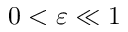Convert formula to latex. <formula><loc_0><loc_0><loc_500><loc_500>0 < \varepsilon \ll 1</formula> 